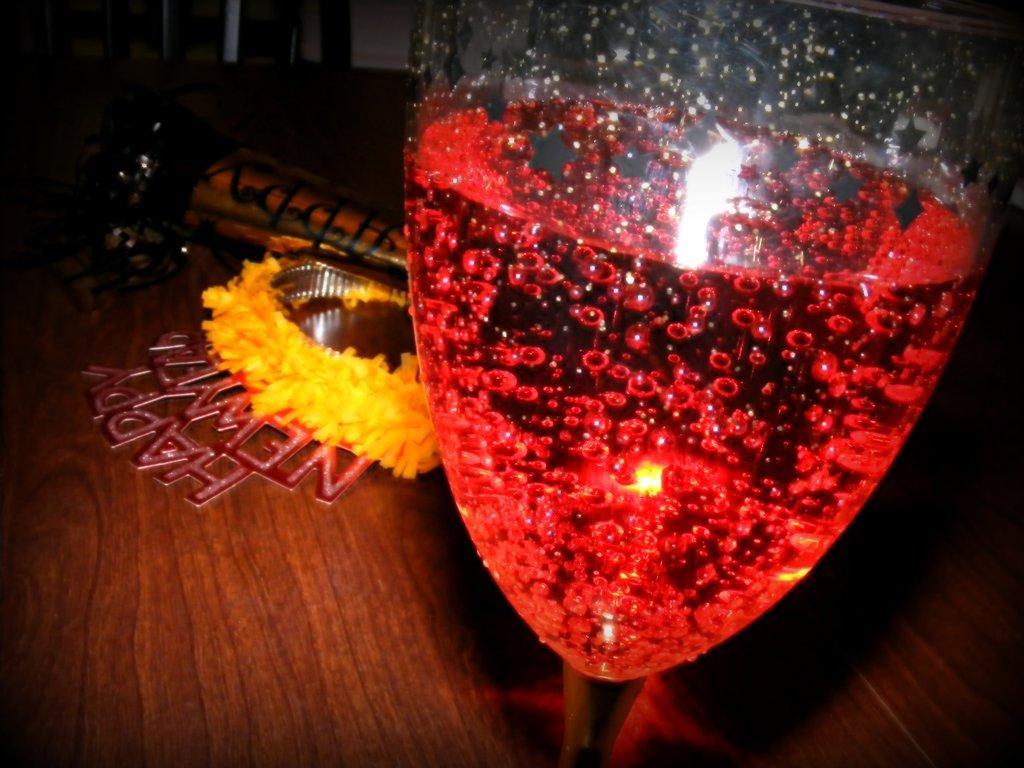In one or two sentences, can you explain what this image depicts? In the picture we can see a wooden table on it, we can see a glass with a drink which is red in color with bubbles in it and beside the glass we can see some decoration items are placed on the table. 